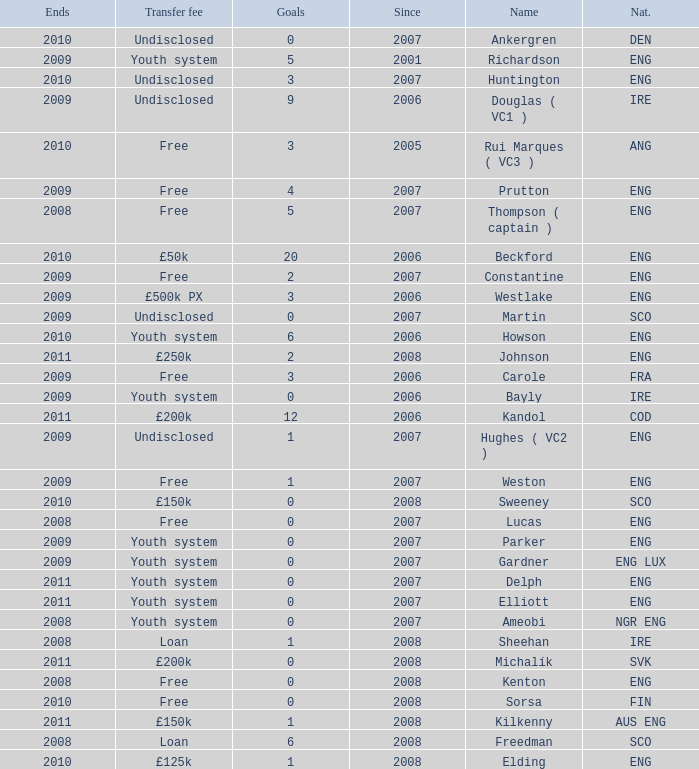Name the average ends for weston 2009.0. 